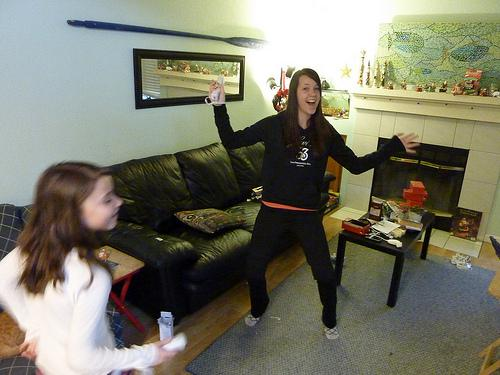Question: who is playing the game?
Choices:
A. Girls.
B. Boys.
C. Boys and girls.
D. Nobody.
Answer with the letter. Answer: A Question: what is on the couch?
Choices:
A. A blanket.
B. A person.
C. A cat.
D. Pillow.
Answer with the letter. Answer: D Question: what are the girls playing?
Choices:
A. Wii.
B. Playstation.
C. Xbox.
D. Nintendo 64.
Answer with the letter. Answer: A Question: where are they located?
Choices:
A. Living room.
B. Bedroom.
C. Kitchen.
D. Bathroom.
Answer with the letter. Answer: A Question: why are they playing the wii?
Choices:
A. To exercise.
B. They were bored.
C. To have fun.
D. They got a new game.
Answer with the letter. Answer: C 